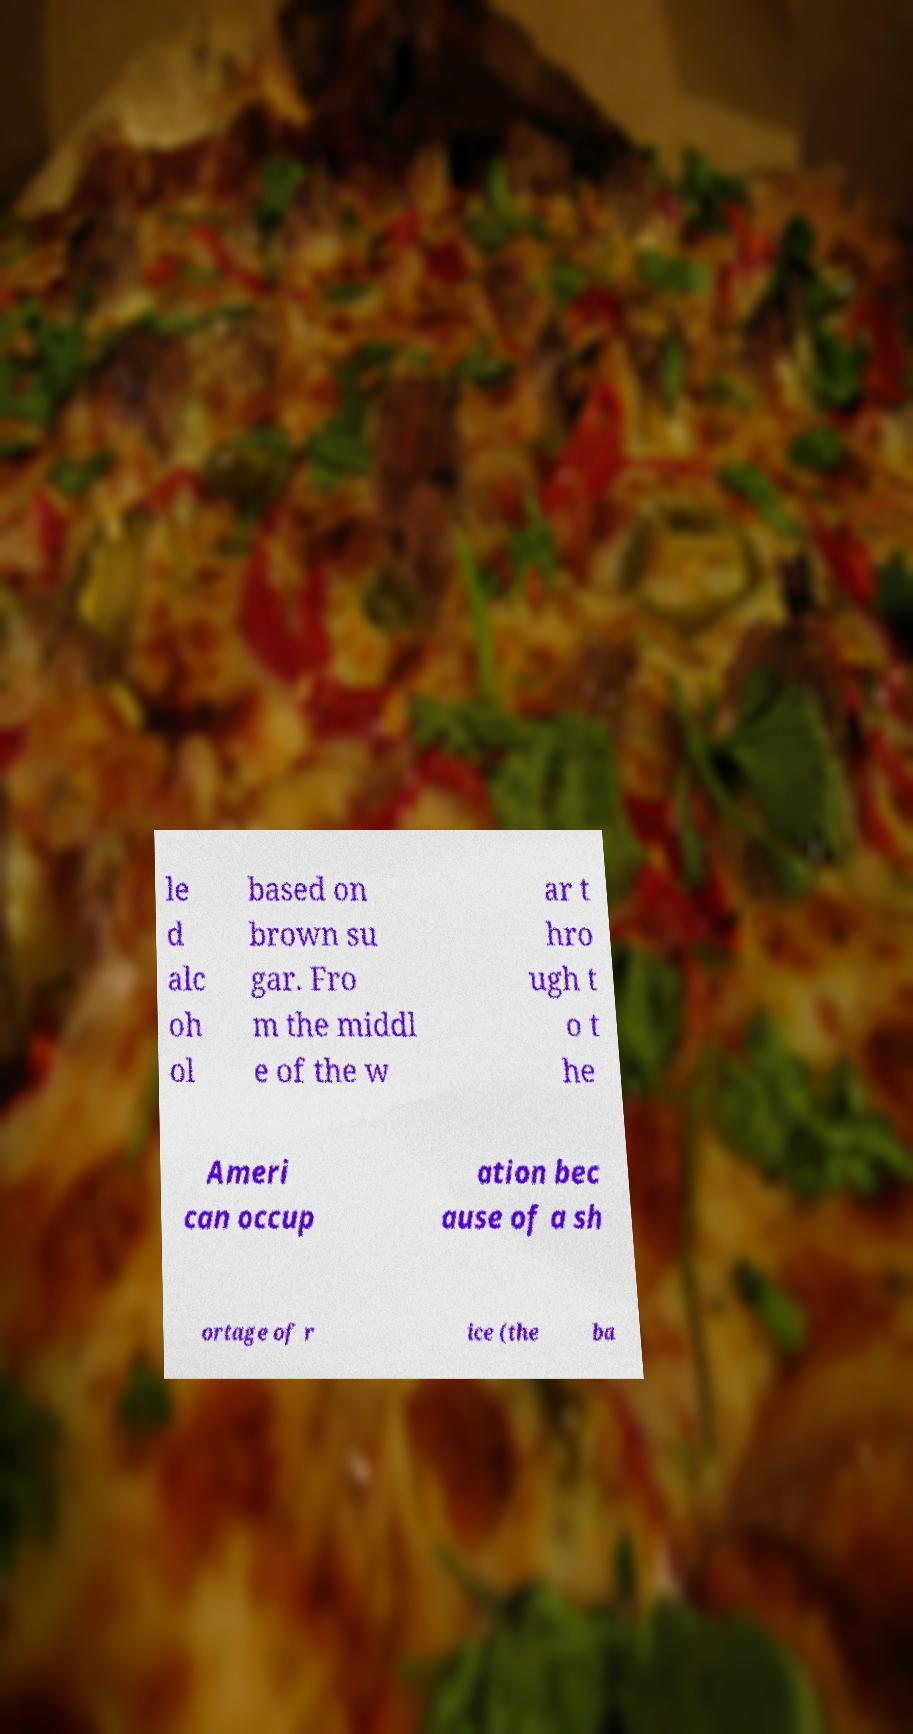What messages or text are displayed in this image? I need them in a readable, typed format. le d alc oh ol based on brown su gar. Fro m the middl e of the w ar t hro ugh t o t he Ameri can occup ation bec ause of a sh ortage of r ice (the ba 